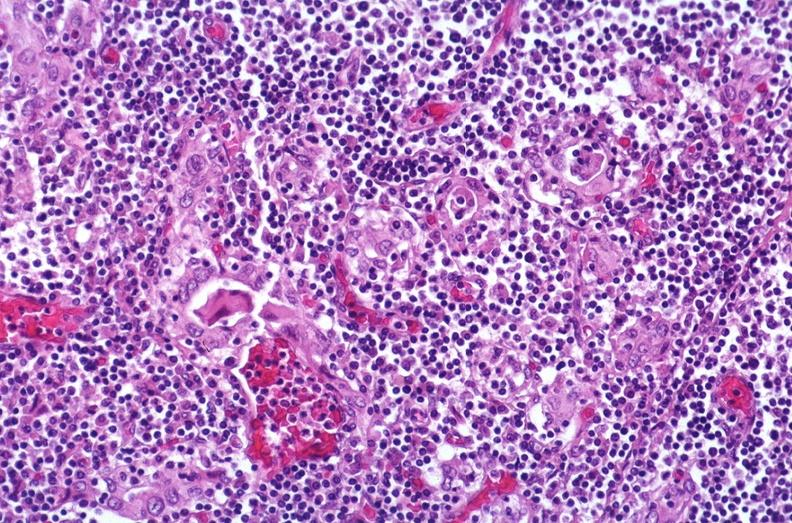s endocrine present?
Answer the question using a single word or phrase. Yes 